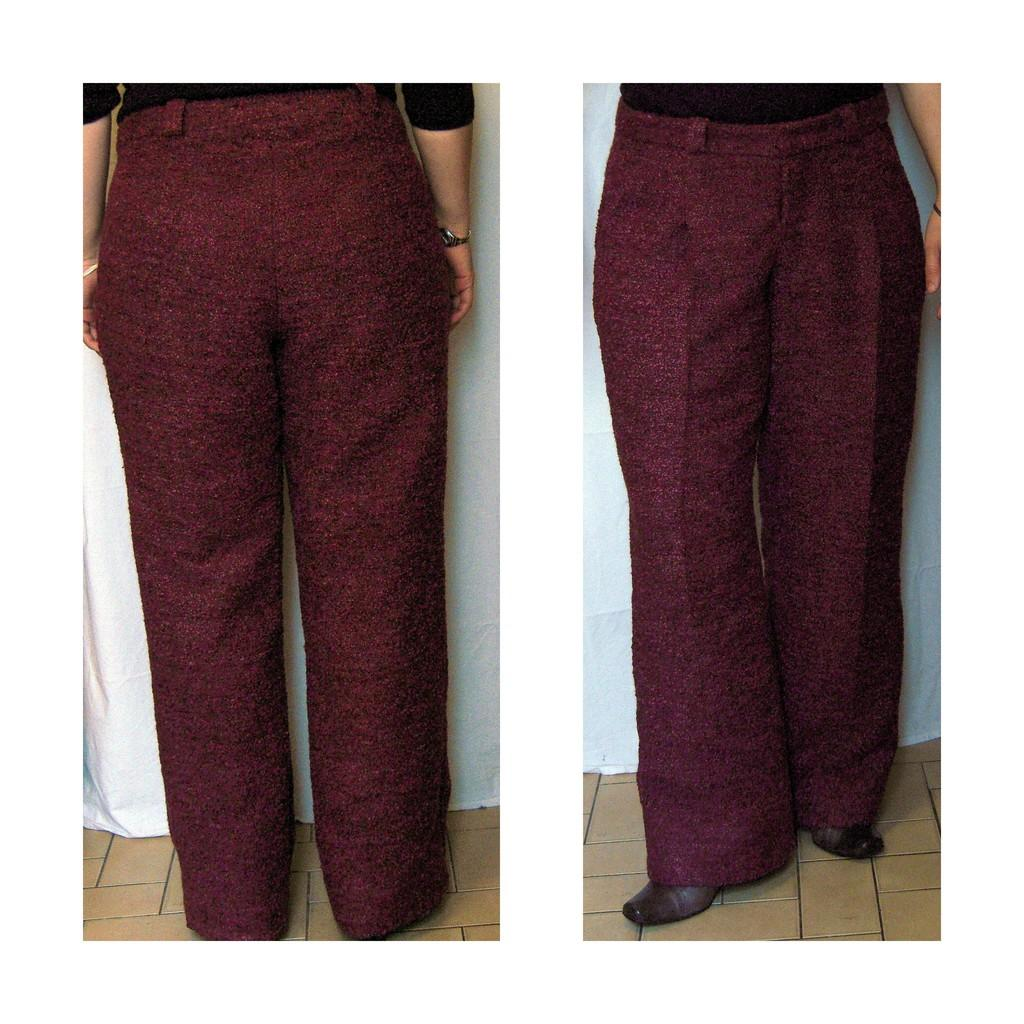What color is the pant that appears in both images of the collage? The pant is red. Can you describe the background of the collage? The background of the collage is white. What type of voice can be heard coming from the oatmeal in the image? There is no oatmeal present in the image, and therefore no voice can be heard from it. 